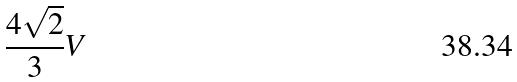Convert formula to latex. <formula><loc_0><loc_0><loc_500><loc_500>\frac { 4 \sqrt { 2 } } { 3 } V</formula> 